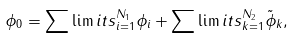<formula> <loc_0><loc_0><loc_500><loc_500>\phi _ { 0 } = \sum \lim i t s _ { i = 1 } ^ { N _ { 1 } } \phi _ { i } + \sum \lim i t s _ { k = 1 } ^ { N _ { 2 } } \tilde { \phi } _ { k } ,</formula> 